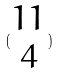<formula> <loc_0><loc_0><loc_500><loc_500>( \begin{matrix} 1 1 \\ 4 \end{matrix} )</formula> 